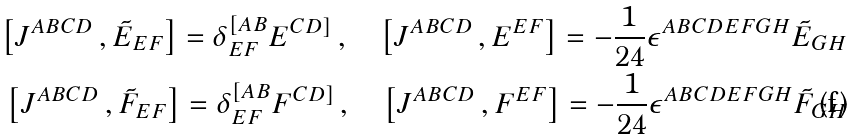Convert formula to latex. <formula><loc_0><loc_0><loc_500><loc_500>\left [ J ^ { A B C D } \, , \tilde { E } _ { E F } \right ] = \delta ^ { [ A B } _ { E F } E ^ { C D ] } \, , \quad \left [ J ^ { A B C D } \, , E ^ { E F } \right ] = - \frac { 1 } { 2 4 } \epsilon ^ { A B C D E F G H } \tilde { E } _ { G H } \, \\ \left [ J ^ { A B C D } \, , \tilde { F } _ { E F } \right ] = \delta ^ { [ A B } _ { E F } F ^ { C D ] } \, , \quad \left [ J ^ { A B C D } \, , F ^ { E F } \right ] = - \frac { 1 } { 2 4 } \epsilon ^ { A B C D E F G H } \tilde { F } _ { G H } \,</formula> 